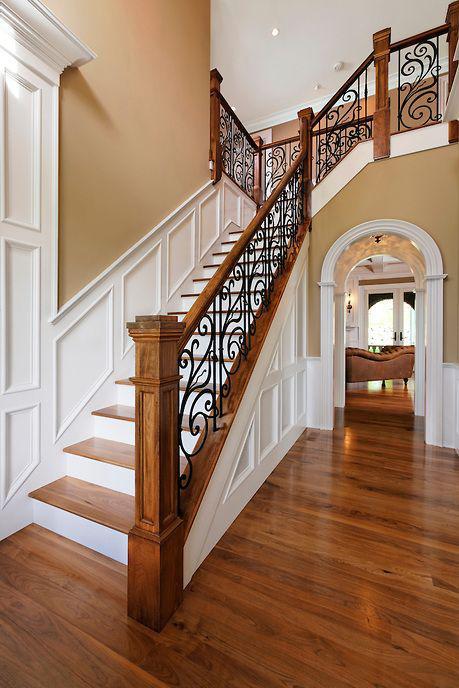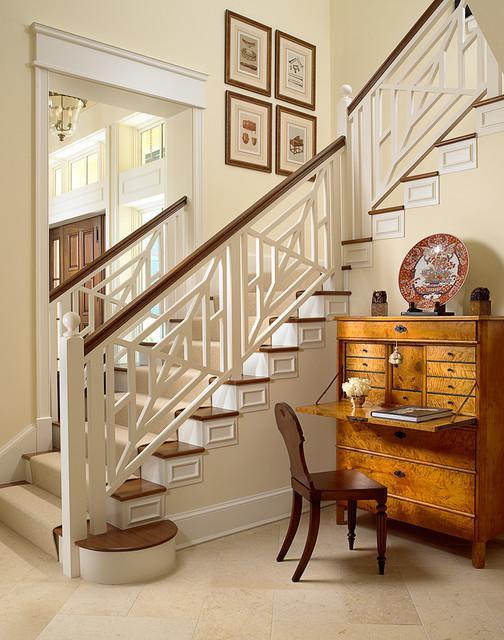The first image is the image on the left, the second image is the image on the right. Given the left and right images, does the statement "An image shows a wooden-railed staircase that ascends rightward before turning, and has black wrought iron vertical bars with S scroll shapes." hold true? Answer yes or no. Yes. The first image is the image on the left, the second image is the image on the right. Examine the images to the left and right. Is the description "In one of the images there is a small door underneath a staircase." accurate? Answer yes or no. No. 